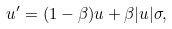Convert formula to latex. <formula><loc_0><loc_0><loc_500><loc_500>u ^ { \prime } = ( 1 - \beta ) u + \beta | u | \sigma , \</formula> 